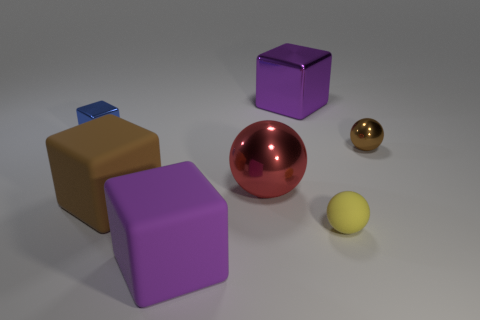Subtract 1 balls. How many balls are left? 2 Subtract all brown cubes. How many cubes are left? 3 Subtract all purple metallic blocks. How many blocks are left? 3 Subtract all gray cubes. Subtract all gray cylinders. How many cubes are left? 4 Add 3 small brown spheres. How many objects exist? 10 Subtract all spheres. How many objects are left? 4 Subtract 0 cyan blocks. How many objects are left? 7 Subtract all brown spheres. Subtract all large spheres. How many objects are left? 5 Add 5 red metallic objects. How many red metallic objects are left? 6 Add 5 gray rubber cubes. How many gray rubber cubes exist? 5 